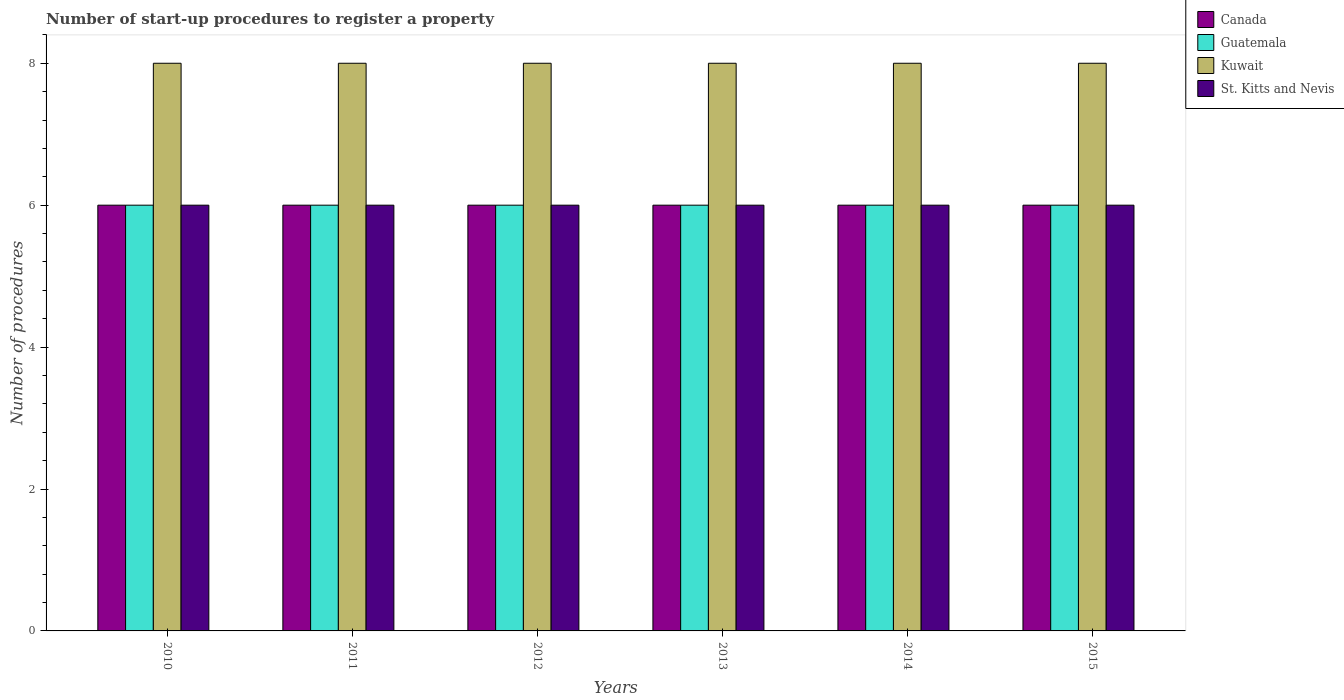How many different coloured bars are there?
Provide a succinct answer. 4. How many groups of bars are there?
Offer a very short reply. 6. Are the number of bars on each tick of the X-axis equal?
Offer a very short reply. Yes. How many bars are there on the 6th tick from the left?
Your response must be concise. 4. How many bars are there on the 6th tick from the right?
Offer a very short reply. 4. What is the label of the 6th group of bars from the left?
Your answer should be very brief. 2015. Across all years, what is the maximum number of procedures required to register a property in Kuwait?
Make the answer very short. 8. Across all years, what is the minimum number of procedures required to register a property in Canada?
Provide a succinct answer. 6. In which year was the number of procedures required to register a property in Guatemala maximum?
Your answer should be compact. 2010. In which year was the number of procedures required to register a property in Canada minimum?
Offer a terse response. 2010. What is the difference between the number of procedures required to register a property in St. Kitts and Nevis in 2011 and that in 2013?
Your answer should be compact. 0. In the year 2010, what is the difference between the number of procedures required to register a property in Guatemala and number of procedures required to register a property in Canada?
Your answer should be compact. 0. Is the difference between the number of procedures required to register a property in Guatemala in 2013 and 2015 greater than the difference between the number of procedures required to register a property in Canada in 2013 and 2015?
Provide a short and direct response. No. What is the difference between the highest and the second highest number of procedures required to register a property in Guatemala?
Keep it short and to the point. 0. What is the difference between the highest and the lowest number of procedures required to register a property in Canada?
Give a very brief answer. 0. What does the 4th bar from the left in 2013 represents?
Provide a short and direct response. St. Kitts and Nevis. What does the 2nd bar from the right in 2015 represents?
Offer a very short reply. Kuwait. How many bars are there?
Make the answer very short. 24. How many years are there in the graph?
Offer a very short reply. 6. Are the values on the major ticks of Y-axis written in scientific E-notation?
Provide a short and direct response. No. Does the graph contain grids?
Your response must be concise. No. How many legend labels are there?
Your answer should be very brief. 4. What is the title of the graph?
Provide a succinct answer. Number of start-up procedures to register a property. What is the label or title of the X-axis?
Your answer should be compact. Years. What is the label or title of the Y-axis?
Give a very brief answer. Number of procedures. What is the Number of procedures of Canada in 2010?
Offer a very short reply. 6. What is the Number of procedures in St. Kitts and Nevis in 2010?
Keep it short and to the point. 6. What is the Number of procedures in Canada in 2011?
Give a very brief answer. 6. What is the Number of procedures in Kuwait in 2011?
Offer a terse response. 8. What is the Number of procedures in St. Kitts and Nevis in 2011?
Your answer should be compact. 6. What is the Number of procedures of Canada in 2013?
Keep it short and to the point. 6. What is the Number of procedures in Kuwait in 2013?
Provide a succinct answer. 8. What is the Number of procedures of St. Kitts and Nevis in 2013?
Keep it short and to the point. 6. What is the Number of procedures of Kuwait in 2014?
Provide a succinct answer. 8. What is the Number of procedures of Canada in 2015?
Provide a short and direct response. 6. What is the Number of procedures in Guatemala in 2015?
Ensure brevity in your answer.  6. Across all years, what is the maximum Number of procedures of Guatemala?
Provide a succinct answer. 6. Across all years, what is the maximum Number of procedures of St. Kitts and Nevis?
Ensure brevity in your answer.  6. Across all years, what is the minimum Number of procedures in Guatemala?
Give a very brief answer. 6. Across all years, what is the minimum Number of procedures in St. Kitts and Nevis?
Make the answer very short. 6. What is the total Number of procedures in Canada in the graph?
Offer a very short reply. 36. What is the total Number of procedures in Kuwait in the graph?
Offer a very short reply. 48. What is the difference between the Number of procedures in Canada in 2010 and that in 2011?
Ensure brevity in your answer.  0. What is the difference between the Number of procedures in Guatemala in 2010 and that in 2011?
Keep it short and to the point. 0. What is the difference between the Number of procedures in Kuwait in 2010 and that in 2011?
Your answer should be very brief. 0. What is the difference between the Number of procedures in St. Kitts and Nevis in 2010 and that in 2011?
Ensure brevity in your answer.  0. What is the difference between the Number of procedures in Guatemala in 2010 and that in 2012?
Make the answer very short. 0. What is the difference between the Number of procedures in St. Kitts and Nevis in 2010 and that in 2012?
Give a very brief answer. 0. What is the difference between the Number of procedures in Guatemala in 2010 and that in 2013?
Provide a succinct answer. 0. What is the difference between the Number of procedures of St. Kitts and Nevis in 2010 and that in 2013?
Provide a succinct answer. 0. What is the difference between the Number of procedures of Guatemala in 2010 and that in 2014?
Keep it short and to the point. 0. What is the difference between the Number of procedures of Kuwait in 2010 and that in 2014?
Make the answer very short. 0. What is the difference between the Number of procedures in Canada in 2010 and that in 2015?
Make the answer very short. 0. What is the difference between the Number of procedures of Kuwait in 2010 and that in 2015?
Your answer should be very brief. 0. What is the difference between the Number of procedures of Guatemala in 2011 and that in 2012?
Offer a terse response. 0. What is the difference between the Number of procedures in Canada in 2011 and that in 2013?
Offer a terse response. 0. What is the difference between the Number of procedures in Guatemala in 2011 and that in 2013?
Your response must be concise. 0. What is the difference between the Number of procedures in Kuwait in 2011 and that in 2013?
Your answer should be very brief. 0. What is the difference between the Number of procedures of St. Kitts and Nevis in 2011 and that in 2013?
Make the answer very short. 0. What is the difference between the Number of procedures in St. Kitts and Nevis in 2011 and that in 2014?
Your answer should be very brief. 0. What is the difference between the Number of procedures in Kuwait in 2011 and that in 2015?
Your response must be concise. 0. What is the difference between the Number of procedures of St. Kitts and Nevis in 2011 and that in 2015?
Offer a terse response. 0. What is the difference between the Number of procedures in Canada in 2012 and that in 2014?
Offer a very short reply. 0. What is the difference between the Number of procedures of Guatemala in 2012 and that in 2014?
Give a very brief answer. 0. What is the difference between the Number of procedures in St. Kitts and Nevis in 2012 and that in 2014?
Provide a short and direct response. 0. What is the difference between the Number of procedures in Kuwait in 2012 and that in 2015?
Provide a succinct answer. 0. What is the difference between the Number of procedures in St. Kitts and Nevis in 2012 and that in 2015?
Your answer should be very brief. 0. What is the difference between the Number of procedures of Guatemala in 2013 and that in 2014?
Offer a very short reply. 0. What is the difference between the Number of procedures of Kuwait in 2013 and that in 2014?
Provide a succinct answer. 0. What is the difference between the Number of procedures in Canada in 2013 and that in 2015?
Your response must be concise. 0. What is the difference between the Number of procedures of St. Kitts and Nevis in 2013 and that in 2015?
Provide a short and direct response. 0. What is the difference between the Number of procedures in Canada in 2014 and that in 2015?
Make the answer very short. 0. What is the difference between the Number of procedures in Guatemala in 2014 and that in 2015?
Your answer should be compact. 0. What is the difference between the Number of procedures in Kuwait in 2014 and that in 2015?
Ensure brevity in your answer.  0. What is the difference between the Number of procedures of St. Kitts and Nevis in 2014 and that in 2015?
Offer a terse response. 0. What is the difference between the Number of procedures of Canada in 2010 and the Number of procedures of Guatemala in 2011?
Offer a terse response. 0. What is the difference between the Number of procedures of Canada in 2010 and the Number of procedures of St. Kitts and Nevis in 2011?
Give a very brief answer. 0. What is the difference between the Number of procedures of Kuwait in 2010 and the Number of procedures of St. Kitts and Nevis in 2011?
Provide a succinct answer. 2. What is the difference between the Number of procedures in Canada in 2010 and the Number of procedures in Guatemala in 2012?
Offer a terse response. 0. What is the difference between the Number of procedures in Canada in 2010 and the Number of procedures in Kuwait in 2012?
Provide a short and direct response. -2. What is the difference between the Number of procedures in Canada in 2010 and the Number of procedures in St. Kitts and Nevis in 2012?
Provide a short and direct response. 0. What is the difference between the Number of procedures of Guatemala in 2010 and the Number of procedures of Kuwait in 2012?
Make the answer very short. -2. What is the difference between the Number of procedures of Guatemala in 2010 and the Number of procedures of St. Kitts and Nevis in 2012?
Provide a short and direct response. 0. What is the difference between the Number of procedures of Kuwait in 2010 and the Number of procedures of St. Kitts and Nevis in 2012?
Give a very brief answer. 2. What is the difference between the Number of procedures of Canada in 2010 and the Number of procedures of Guatemala in 2013?
Give a very brief answer. 0. What is the difference between the Number of procedures in Kuwait in 2010 and the Number of procedures in St. Kitts and Nevis in 2013?
Give a very brief answer. 2. What is the difference between the Number of procedures in Canada in 2010 and the Number of procedures in Kuwait in 2014?
Keep it short and to the point. -2. What is the difference between the Number of procedures of Canada in 2010 and the Number of procedures of St. Kitts and Nevis in 2014?
Your response must be concise. 0. What is the difference between the Number of procedures of Guatemala in 2010 and the Number of procedures of Kuwait in 2014?
Your answer should be compact. -2. What is the difference between the Number of procedures in Guatemala in 2010 and the Number of procedures in St. Kitts and Nevis in 2014?
Offer a terse response. 0. What is the difference between the Number of procedures of Kuwait in 2010 and the Number of procedures of St. Kitts and Nevis in 2014?
Provide a succinct answer. 2. What is the difference between the Number of procedures in Canada in 2010 and the Number of procedures in St. Kitts and Nevis in 2015?
Offer a very short reply. 0. What is the difference between the Number of procedures in Guatemala in 2010 and the Number of procedures in Kuwait in 2015?
Your response must be concise. -2. What is the difference between the Number of procedures in Kuwait in 2010 and the Number of procedures in St. Kitts and Nevis in 2015?
Your answer should be very brief. 2. What is the difference between the Number of procedures of Kuwait in 2011 and the Number of procedures of St. Kitts and Nevis in 2012?
Make the answer very short. 2. What is the difference between the Number of procedures in Canada in 2011 and the Number of procedures in Guatemala in 2013?
Your answer should be very brief. 0. What is the difference between the Number of procedures of Canada in 2011 and the Number of procedures of Kuwait in 2013?
Offer a terse response. -2. What is the difference between the Number of procedures in Canada in 2011 and the Number of procedures in St. Kitts and Nevis in 2013?
Make the answer very short. 0. What is the difference between the Number of procedures in Guatemala in 2011 and the Number of procedures in St. Kitts and Nevis in 2013?
Your answer should be very brief. 0. What is the difference between the Number of procedures in Canada in 2011 and the Number of procedures in Kuwait in 2014?
Offer a very short reply. -2. What is the difference between the Number of procedures of Kuwait in 2011 and the Number of procedures of St. Kitts and Nevis in 2014?
Make the answer very short. 2. What is the difference between the Number of procedures in Canada in 2011 and the Number of procedures in St. Kitts and Nevis in 2015?
Ensure brevity in your answer.  0. What is the difference between the Number of procedures in Guatemala in 2011 and the Number of procedures in St. Kitts and Nevis in 2015?
Give a very brief answer. 0. What is the difference between the Number of procedures of Canada in 2012 and the Number of procedures of Kuwait in 2013?
Your answer should be compact. -2. What is the difference between the Number of procedures in Canada in 2012 and the Number of procedures in St. Kitts and Nevis in 2013?
Your answer should be compact. 0. What is the difference between the Number of procedures of Guatemala in 2012 and the Number of procedures of Kuwait in 2013?
Offer a terse response. -2. What is the difference between the Number of procedures in Guatemala in 2012 and the Number of procedures in St. Kitts and Nevis in 2013?
Provide a short and direct response. 0. What is the difference between the Number of procedures of Kuwait in 2012 and the Number of procedures of St. Kitts and Nevis in 2013?
Provide a short and direct response. 2. What is the difference between the Number of procedures of Canada in 2012 and the Number of procedures of Guatemala in 2014?
Give a very brief answer. 0. What is the difference between the Number of procedures of Canada in 2012 and the Number of procedures of St. Kitts and Nevis in 2015?
Your answer should be compact. 0. What is the difference between the Number of procedures of Guatemala in 2012 and the Number of procedures of Kuwait in 2015?
Your answer should be compact. -2. What is the difference between the Number of procedures of Guatemala in 2012 and the Number of procedures of St. Kitts and Nevis in 2015?
Make the answer very short. 0. What is the difference between the Number of procedures in Kuwait in 2012 and the Number of procedures in St. Kitts and Nevis in 2015?
Provide a short and direct response. 2. What is the difference between the Number of procedures of Canada in 2013 and the Number of procedures of Guatemala in 2014?
Provide a short and direct response. 0. What is the difference between the Number of procedures of Canada in 2013 and the Number of procedures of St. Kitts and Nevis in 2014?
Offer a very short reply. 0. What is the difference between the Number of procedures in Canada in 2013 and the Number of procedures in Guatemala in 2015?
Your answer should be compact. 0. What is the difference between the Number of procedures in Canada in 2013 and the Number of procedures in Kuwait in 2015?
Offer a terse response. -2. What is the difference between the Number of procedures of Canada in 2013 and the Number of procedures of St. Kitts and Nevis in 2015?
Ensure brevity in your answer.  0. What is the difference between the Number of procedures of Guatemala in 2013 and the Number of procedures of Kuwait in 2015?
Your answer should be very brief. -2. What is the difference between the Number of procedures in Kuwait in 2013 and the Number of procedures in St. Kitts and Nevis in 2015?
Your answer should be very brief. 2. What is the difference between the Number of procedures in Canada in 2014 and the Number of procedures in Kuwait in 2015?
Your answer should be very brief. -2. What is the difference between the Number of procedures of Guatemala in 2014 and the Number of procedures of St. Kitts and Nevis in 2015?
Ensure brevity in your answer.  0. What is the average Number of procedures of Guatemala per year?
Give a very brief answer. 6. What is the average Number of procedures of St. Kitts and Nevis per year?
Your answer should be very brief. 6. In the year 2010, what is the difference between the Number of procedures of Canada and Number of procedures of Guatemala?
Offer a very short reply. 0. In the year 2010, what is the difference between the Number of procedures of Canada and Number of procedures of Kuwait?
Provide a short and direct response. -2. In the year 2010, what is the difference between the Number of procedures in Canada and Number of procedures in St. Kitts and Nevis?
Your answer should be very brief. 0. In the year 2010, what is the difference between the Number of procedures of Guatemala and Number of procedures of St. Kitts and Nevis?
Provide a short and direct response. 0. In the year 2011, what is the difference between the Number of procedures in Canada and Number of procedures in Guatemala?
Offer a terse response. 0. In the year 2011, what is the difference between the Number of procedures of Guatemala and Number of procedures of Kuwait?
Give a very brief answer. -2. In the year 2011, what is the difference between the Number of procedures in Guatemala and Number of procedures in St. Kitts and Nevis?
Make the answer very short. 0. In the year 2011, what is the difference between the Number of procedures of Kuwait and Number of procedures of St. Kitts and Nevis?
Your answer should be very brief. 2. In the year 2013, what is the difference between the Number of procedures in Canada and Number of procedures in Guatemala?
Your response must be concise. 0. In the year 2013, what is the difference between the Number of procedures of Guatemala and Number of procedures of St. Kitts and Nevis?
Give a very brief answer. 0. In the year 2014, what is the difference between the Number of procedures in Guatemala and Number of procedures in St. Kitts and Nevis?
Provide a succinct answer. 0. In the year 2014, what is the difference between the Number of procedures of Kuwait and Number of procedures of St. Kitts and Nevis?
Provide a succinct answer. 2. In the year 2015, what is the difference between the Number of procedures of Canada and Number of procedures of Guatemala?
Your answer should be very brief. 0. In the year 2015, what is the difference between the Number of procedures in Canada and Number of procedures in Kuwait?
Offer a terse response. -2. In the year 2015, what is the difference between the Number of procedures in Guatemala and Number of procedures in Kuwait?
Keep it short and to the point. -2. In the year 2015, what is the difference between the Number of procedures in Kuwait and Number of procedures in St. Kitts and Nevis?
Offer a very short reply. 2. What is the ratio of the Number of procedures in Canada in 2010 to that in 2011?
Provide a short and direct response. 1. What is the ratio of the Number of procedures of Guatemala in 2010 to that in 2011?
Your answer should be compact. 1. What is the ratio of the Number of procedures in St. Kitts and Nevis in 2010 to that in 2011?
Ensure brevity in your answer.  1. What is the ratio of the Number of procedures of Canada in 2010 to that in 2012?
Offer a terse response. 1. What is the ratio of the Number of procedures in Guatemala in 2010 to that in 2012?
Provide a succinct answer. 1. What is the ratio of the Number of procedures of St. Kitts and Nevis in 2010 to that in 2012?
Your answer should be compact. 1. What is the ratio of the Number of procedures of Kuwait in 2010 to that in 2013?
Make the answer very short. 1. What is the ratio of the Number of procedures in St. Kitts and Nevis in 2010 to that in 2013?
Provide a succinct answer. 1. What is the ratio of the Number of procedures of Guatemala in 2010 to that in 2014?
Give a very brief answer. 1. What is the ratio of the Number of procedures of St. Kitts and Nevis in 2010 to that in 2014?
Give a very brief answer. 1. What is the ratio of the Number of procedures in Kuwait in 2011 to that in 2012?
Ensure brevity in your answer.  1. What is the ratio of the Number of procedures of Canada in 2011 to that in 2013?
Keep it short and to the point. 1. What is the ratio of the Number of procedures in Kuwait in 2011 to that in 2013?
Provide a succinct answer. 1. What is the ratio of the Number of procedures of St. Kitts and Nevis in 2011 to that in 2013?
Give a very brief answer. 1. What is the ratio of the Number of procedures of Canada in 2011 to that in 2014?
Keep it short and to the point. 1. What is the ratio of the Number of procedures in Guatemala in 2011 to that in 2014?
Make the answer very short. 1. What is the ratio of the Number of procedures of St. Kitts and Nevis in 2011 to that in 2014?
Your answer should be compact. 1. What is the ratio of the Number of procedures of St. Kitts and Nevis in 2011 to that in 2015?
Offer a very short reply. 1. What is the ratio of the Number of procedures of Canada in 2012 to that in 2013?
Offer a very short reply. 1. What is the ratio of the Number of procedures of Guatemala in 2012 to that in 2013?
Offer a very short reply. 1. What is the ratio of the Number of procedures of St. Kitts and Nevis in 2012 to that in 2013?
Ensure brevity in your answer.  1. What is the ratio of the Number of procedures in Guatemala in 2012 to that in 2014?
Provide a short and direct response. 1. What is the ratio of the Number of procedures in St. Kitts and Nevis in 2012 to that in 2014?
Provide a succinct answer. 1. What is the ratio of the Number of procedures in Guatemala in 2012 to that in 2015?
Ensure brevity in your answer.  1. What is the ratio of the Number of procedures in Guatemala in 2013 to that in 2014?
Your response must be concise. 1. What is the ratio of the Number of procedures of Canada in 2013 to that in 2015?
Ensure brevity in your answer.  1. What is the ratio of the Number of procedures of Guatemala in 2013 to that in 2015?
Your answer should be very brief. 1. What is the ratio of the Number of procedures in St. Kitts and Nevis in 2013 to that in 2015?
Provide a short and direct response. 1. What is the ratio of the Number of procedures of Canada in 2014 to that in 2015?
Provide a succinct answer. 1. What is the ratio of the Number of procedures in St. Kitts and Nevis in 2014 to that in 2015?
Offer a very short reply. 1. What is the difference between the highest and the second highest Number of procedures of Guatemala?
Offer a terse response. 0. What is the difference between the highest and the second highest Number of procedures of St. Kitts and Nevis?
Provide a short and direct response. 0. What is the difference between the highest and the lowest Number of procedures of Canada?
Ensure brevity in your answer.  0. What is the difference between the highest and the lowest Number of procedures in Kuwait?
Your answer should be compact. 0. What is the difference between the highest and the lowest Number of procedures of St. Kitts and Nevis?
Make the answer very short. 0. 